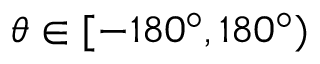Convert formula to latex. <formula><loc_0><loc_0><loc_500><loc_500>\theta \in [ - 1 8 0 ^ { \circ } , 1 8 0 ^ { \circ } )</formula> 